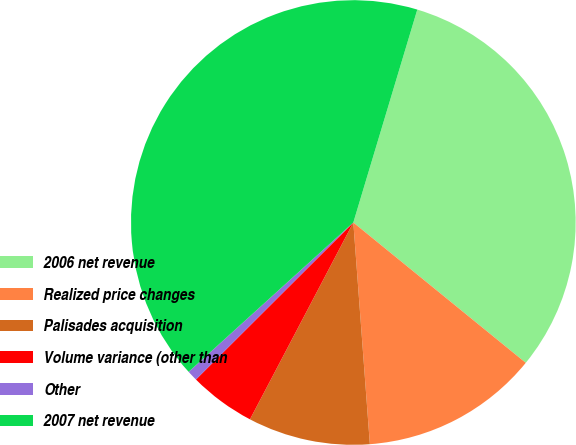<chart> <loc_0><loc_0><loc_500><loc_500><pie_chart><fcel>2006 net revenue<fcel>Realized price changes<fcel>Palisades acquisition<fcel>Volume variance (other than<fcel>Other<fcel>2007 net revenue<nl><fcel>31.22%<fcel>12.94%<fcel>8.88%<fcel>4.82%<fcel>0.76%<fcel>41.36%<nl></chart> 